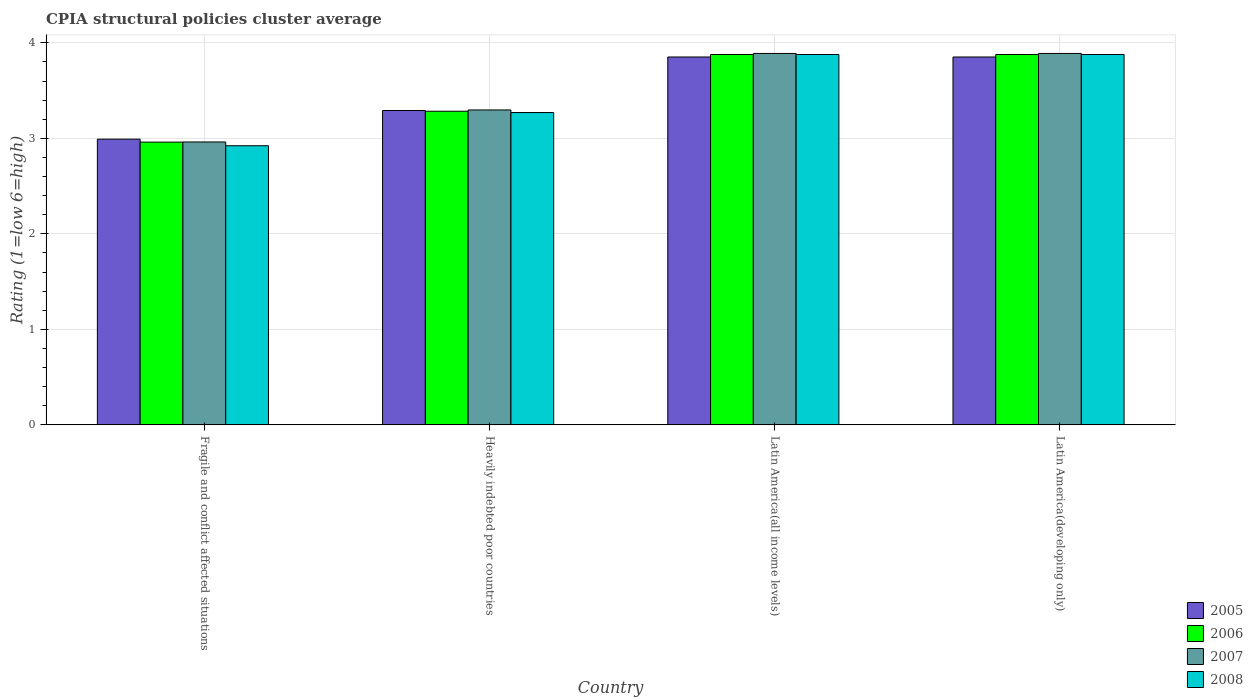Are the number of bars per tick equal to the number of legend labels?
Your answer should be compact. Yes. Are the number of bars on each tick of the X-axis equal?
Offer a terse response. Yes. How many bars are there on the 1st tick from the left?
Your answer should be compact. 4. How many bars are there on the 4th tick from the right?
Offer a very short reply. 4. What is the label of the 3rd group of bars from the left?
Provide a short and direct response. Latin America(all income levels). What is the CPIA rating in 2005 in Latin America(all income levels)?
Ensure brevity in your answer.  3.85. Across all countries, what is the maximum CPIA rating in 2008?
Keep it short and to the point. 3.88. Across all countries, what is the minimum CPIA rating in 2008?
Give a very brief answer. 2.92. In which country was the CPIA rating in 2006 maximum?
Offer a very short reply. Latin America(all income levels). In which country was the CPIA rating in 2006 minimum?
Your answer should be very brief. Fragile and conflict affected situations. What is the total CPIA rating in 2005 in the graph?
Ensure brevity in your answer.  13.99. What is the difference between the CPIA rating in 2008 in Heavily indebted poor countries and that in Latin America(developing only)?
Give a very brief answer. -0.61. What is the difference between the CPIA rating in 2008 in Fragile and conflict affected situations and the CPIA rating in 2006 in Heavily indebted poor countries?
Offer a terse response. -0.36. What is the average CPIA rating in 2007 per country?
Your response must be concise. 3.51. What is the difference between the CPIA rating of/in 2005 and CPIA rating of/in 2008 in Fragile and conflict affected situations?
Your response must be concise. 0.07. What is the ratio of the CPIA rating in 2006 in Fragile and conflict affected situations to that in Latin America(developing only)?
Provide a succinct answer. 0.76. Is the difference between the CPIA rating in 2005 in Fragile and conflict affected situations and Latin America(developing only) greater than the difference between the CPIA rating in 2008 in Fragile and conflict affected situations and Latin America(developing only)?
Your response must be concise. Yes. What is the difference between the highest and the second highest CPIA rating in 2007?
Offer a very short reply. -0.59. What is the difference between the highest and the lowest CPIA rating in 2008?
Keep it short and to the point. 0.96. Is it the case that in every country, the sum of the CPIA rating in 2008 and CPIA rating in 2006 is greater than the sum of CPIA rating in 2005 and CPIA rating in 2007?
Make the answer very short. No. What does the 3rd bar from the right in Heavily indebted poor countries represents?
Make the answer very short. 2006. Are all the bars in the graph horizontal?
Provide a succinct answer. No. How many countries are there in the graph?
Offer a very short reply. 4. Are the values on the major ticks of Y-axis written in scientific E-notation?
Your answer should be very brief. No. Does the graph contain any zero values?
Offer a terse response. No. Does the graph contain grids?
Provide a succinct answer. Yes. Where does the legend appear in the graph?
Offer a terse response. Bottom right. How many legend labels are there?
Offer a terse response. 4. What is the title of the graph?
Your answer should be compact. CPIA structural policies cluster average. Does "2013" appear as one of the legend labels in the graph?
Offer a very short reply. No. What is the label or title of the Y-axis?
Your response must be concise. Rating (1=low 6=high). What is the Rating (1=low 6=high) of 2005 in Fragile and conflict affected situations?
Provide a succinct answer. 2.99. What is the Rating (1=low 6=high) of 2006 in Fragile and conflict affected situations?
Keep it short and to the point. 2.96. What is the Rating (1=low 6=high) in 2007 in Fragile and conflict affected situations?
Your answer should be very brief. 2.96. What is the Rating (1=low 6=high) in 2008 in Fragile and conflict affected situations?
Ensure brevity in your answer.  2.92. What is the Rating (1=low 6=high) in 2005 in Heavily indebted poor countries?
Your answer should be very brief. 3.29. What is the Rating (1=low 6=high) in 2006 in Heavily indebted poor countries?
Offer a very short reply. 3.28. What is the Rating (1=low 6=high) of 2007 in Heavily indebted poor countries?
Your answer should be very brief. 3.3. What is the Rating (1=low 6=high) of 2008 in Heavily indebted poor countries?
Give a very brief answer. 3.27. What is the Rating (1=low 6=high) of 2005 in Latin America(all income levels)?
Offer a terse response. 3.85. What is the Rating (1=low 6=high) in 2006 in Latin America(all income levels)?
Keep it short and to the point. 3.88. What is the Rating (1=low 6=high) of 2007 in Latin America(all income levels)?
Make the answer very short. 3.89. What is the Rating (1=low 6=high) in 2008 in Latin America(all income levels)?
Offer a very short reply. 3.88. What is the Rating (1=low 6=high) of 2005 in Latin America(developing only)?
Keep it short and to the point. 3.85. What is the Rating (1=low 6=high) of 2006 in Latin America(developing only)?
Your answer should be compact. 3.88. What is the Rating (1=low 6=high) of 2007 in Latin America(developing only)?
Give a very brief answer. 3.89. What is the Rating (1=low 6=high) of 2008 in Latin America(developing only)?
Provide a succinct answer. 3.88. Across all countries, what is the maximum Rating (1=low 6=high) of 2005?
Your answer should be compact. 3.85. Across all countries, what is the maximum Rating (1=low 6=high) in 2006?
Your response must be concise. 3.88. Across all countries, what is the maximum Rating (1=low 6=high) of 2007?
Offer a very short reply. 3.89. Across all countries, what is the maximum Rating (1=low 6=high) in 2008?
Keep it short and to the point. 3.88. Across all countries, what is the minimum Rating (1=low 6=high) in 2005?
Your response must be concise. 2.99. Across all countries, what is the minimum Rating (1=low 6=high) in 2006?
Make the answer very short. 2.96. Across all countries, what is the minimum Rating (1=low 6=high) in 2007?
Your answer should be very brief. 2.96. Across all countries, what is the minimum Rating (1=low 6=high) of 2008?
Provide a short and direct response. 2.92. What is the total Rating (1=low 6=high) in 2005 in the graph?
Provide a succinct answer. 13.99. What is the total Rating (1=low 6=high) in 2006 in the graph?
Your answer should be very brief. 14. What is the total Rating (1=low 6=high) in 2007 in the graph?
Your answer should be compact. 14.04. What is the total Rating (1=low 6=high) in 2008 in the graph?
Offer a very short reply. 13.95. What is the difference between the Rating (1=low 6=high) in 2006 in Fragile and conflict affected situations and that in Heavily indebted poor countries?
Offer a terse response. -0.32. What is the difference between the Rating (1=low 6=high) in 2007 in Fragile and conflict affected situations and that in Heavily indebted poor countries?
Make the answer very short. -0.34. What is the difference between the Rating (1=low 6=high) of 2008 in Fragile and conflict affected situations and that in Heavily indebted poor countries?
Give a very brief answer. -0.35. What is the difference between the Rating (1=low 6=high) in 2005 in Fragile and conflict affected situations and that in Latin America(all income levels)?
Make the answer very short. -0.86. What is the difference between the Rating (1=low 6=high) of 2006 in Fragile and conflict affected situations and that in Latin America(all income levels)?
Make the answer very short. -0.92. What is the difference between the Rating (1=low 6=high) of 2007 in Fragile and conflict affected situations and that in Latin America(all income levels)?
Offer a terse response. -0.93. What is the difference between the Rating (1=low 6=high) in 2008 in Fragile and conflict affected situations and that in Latin America(all income levels)?
Give a very brief answer. -0.96. What is the difference between the Rating (1=low 6=high) in 2005 in Fragile and conflict affected situations and that in Latin America(developing only)?
Make the answer very short. -0.86. What is the difference between the Rating (1=low 6=high) of 2006 in Fragile and conflict affected situations and that in Latin America(developing only)?
Offer a terse response. -0.92. What is the difference between the Rating (1=low 6=high) of 2007 in Fragile and conflict affected situations and that in Latin America(developing only)?
Offer a very short reply. -0.93. What is the difference between the Rating (1=low 6=high) in 2008 in Fragile and conflict affected situations and that in Latin America(developing only)?
Give a very brief answer. -0.96. What is the difference between the Rating (1=low 6=high) of 2005 in Heavily indebted poor countries and that in Latin America(all income levels)?
Make the answer very short. -0.56. What is the difference between the Rating (1=low 6=high) in 2006 in Heavily indebted poor countries and that in Latin America(all income levels)?
Offer a very short reply. -0.59. What is the difference between the Rating (1=low 6=high) of 2007 in Heavily indebted poor countries and that in Latin America(all income levels)?
Your answer should be very brief. -0.59. What is the difference between the Rating (1=low 6=high) of 2008 in Heavily indebted poor countries and that in Latin America(all income levels)?
Make the answer very short. -0.61. What is the difference between the Rating (1=low 6=high) of 2005 in Heavily indebted poor countries and that in Latin America(developing only)?
Your answer should be very brief. -0.56. What is the difference between the Rating (1=low 6=high) in 2006 in Heavily indebted poor countries and that in Latin America(developing only)?
Provide a short and direct response. -0.59. What is the difference between the Rating (1=low 6=high) of 2007 in Heavily indebted poor countries and that in Latin America(developing only)?
Offer a very short reply. -0.59. What is the difference between the Rating (1=low 6=high) of 2008 in Heavily indebted poor countries and that in Latin America(developing only)?
Ensure brevity in your answer.  -0.61. What is the difference between the Rating (1=low 6=high) of 2005 in Latin America(all income levels) and that in Latin America(developing only)?
Your answer should be compact. 0. What is the difference between the Rating (1=low 6=high) of 2006 in Latin America(all income levels) and that in Latin America(developing only)?
Offer a very short reply. 0. What is the difference between the Rating (1=low 6=high) of 2008 in Latin America(all income levels) and that in Latin America(developing only)?
Keep it short and to the point. 0. What is the difference between the Rating (1=low 6=high) in 2005 in Fragile and conflict affected situations and the Rating (1=low 6=high) in 2006 in Heavily indebted poor countries?
Ensure brevity in your answer.  -0.29. What is the difference between the Rating (1=low 6=high) in 2005 in Fragile and conflict affected situations and the Rating (1=low 6=high) in 2007 in Heavily indebted poor countries?
Provide a succinct answer. -0.31. What is the difference between the Rating (1=low 6=high) of 2005 in Fragile and conflict affected situations and the Rating (1=low 6=high) of 2008 in Heavily indebted poor countries?
Your response must be concise. -0.28. What is the difference between the Rating (1=low 6=high) of 2006 in Fragile and conflict affected situations and the Rating (1=low 6=high) of 2007 in Heavily indebted poor countries?
Ensure brevity in your answer.  -0.34. What is the difference between the Rating (1=low 6=high) in 2006 in Fragile and conflict affected situations and the Rating (1=low 6=high) in 2008 in Heavily indebted poor countries?
Ensure brevity in your answer.  -0.31. What is the difference between the Rating (1=low 6=high) of 2007 in Fragile and conflict affected situations and the Rating (1=low 6=high) of 2008 in Heavily indebted poor countries?
Provide a short and direct response. -0.31. What is the difference between the Rating (1=low 6=high) in 2005 in Fragile and conflict affected situations and the Rating (1=low 6=high) in 2006 in Latin America(all income levels)?
Provide a short and direct response. -0.89. What is the difference between the Rating (1=low 6=high) in 2005 in Fragile and conflict affected situations and the Rating (1=low 6=high) in 2007 in Latin America(all income levels)?
Make the answer very short. -0.9. What is the difference between the Rating (1=low 6=high) of 2005 in Fragile and conflict affected situations and the Rating (1=low 6=high) of 2008 in Latin America(all income levels)?
Provide a short and direct response. -0.89. What is the difference between the Rating (1=low 6=high) of 2006 in Fragile and conflict affected situations and the Rating (1=low 6=high) of 2007 in Latin America(all income levels)?
Provide a short and direct response. -0.93. What is the difference between the Rating (1=low 6=high) of 2006 in Fragile and conflict affected situations and the Rating (1=low 6=high) of 2008 in Latin America(all income levels)?
Offer a very short reply. -0.92. What is the difference between the Rating (1=low 6=high) in 2007 in Fragile and conflict affected situations and the Rating (1=low 6=high) in 2008 in Latin America(all income levels)?
Make the answer very short. -0.92. What is the difference between the Rating (1=low 6=high) of 2005 in Fragile and conflict affected situations and the Rating (1=low 6=high) of 2006 in Latin America(developing only)?
Your answer should be compact. -0.89. What is the difference between the Rating (1=low 6=high) in 2005 in Fragile and conflict affected situations and the Rating (1=low 6=high) in 2007 in Latin America(developing only)?
Your answer should be very brief. -0.9. What is the difference between the Rating (1=low 6=high) of 2005 in Fragile and conflict affected situations and the Rating (1=low 6=high) of 2008 in Latin America(developing only)?
Your response must be concise. -0.89. What is the difference between the Rating (1=low 6=high) in 2006 in Fragile and conflict affected situations and the Rating (1=low 6=high) in 2007 in Latin America(developing only)?
Make the answer very short. -0.93. What is the difference between the Rating (1=low 6=high) of 2006 in Fragile and conflict affected situations and the Rating (1=low 6=high) of 2008 in Latin America(developing only)?
Your answer should be very brief. -0.92. What is the difference between the Rating (1=low 6=high) in 2007 in Fragile and conflict affected situations and the Rating (1=low 6=high) in 2008 in Latin America(developing only)?
Give a very brief answer. -0.92. What is the difference between the Rating (1=low 6=high) in 2005 in Heavily indebted poor countries and the Rating (1=low 6=high) in 2006 in Latin America(all income levels)?
Keep it short and to the point. -0.59. What is the difference between the Rating (1=low 6=high) of 2005 in Heavily indebted poor countries and the Rating (1=low 6=high) of 2007 in Latin America(all income levels)?
Your answer should be compact. -0.6. What is the difference between the Rating (1=low 6=high) in 2005 in Heavily indebted poor countries and the Rating (1=low 6=high) in 2008 in Latin America(all income levels)?
Your answer should be very brief. -0.59. What is the difference between the Rating (1=low 6=high) in 2006 in Heavily indebted poor countries and the Rating (1=low 6=high) in 2007 in Latin America(all income levels)?
Offer a terse response. -0.61. What is the difference between the Rating (1=low 6=high) of 2006 in Heavily indebted poor countries and the Rating (1=low 6=high) of 2008 in Latin America(all income levels)?
Give a very brief answer. -0.59. What is the difference between the Rating (1=low 6=high) of 2007 in Heavily indebted poor countries and the Rating (1=low 6=high) of 2008 in Latin America(all income levels)?
Give a very brief answer. -0.58. What is the difference between the Rating (1=low 6=high) in 2005 in Heavily indebted poor countries and the Rating (1=low 6=high) in 2006 in Latin America(developing only)?
Offer a terse response. -0.59. What is the difference between the Rating (1=low 6=high) of 2005 in Heavily indebted poor countries and the Rating (1=low 6=high) of 2007 in Latin America(developing only)?
Your answer should be compact. -0.6. What is the difference between the Rating (1=low 6=high) of 2005 in Heavily indebted poor countries and the Rating (1=low 6=high) of 2008 in Latin America(developing only)?
Your answer should be compact. -0.59. What is the difference between the Rating (1=low 6=high) of 2006 in Heavily indebted poor countries and the Rating (1=low 6=high) of 2007 in Latin America(developing only)?
Your answer should be compact. -0.61. What is the difference between the Rating (1=low 6=high) of 2006 in Heavily indebted poor countries and the Rating (1=low 6=high) of 2008 in Latin America(developing only)?
Keep it short and to the point. -0.59. What is the difference between the Rating (1=low 6=high) of 2007 in Heavily indebted poor countries and the Rating (1=low 6=high) of 2008 in Latin America(developing only)?
Your response must be concise. -0.58. What is the difference between the Rating (1=low 6=high) in 2005 in Latin America(all income levels) and the Rating (1=low 6=high) in 2006 in Latin America(developing only)?
Keep it short and to the point. -0.03. What is the difference between the Rating (1=low 6=high) in 2005 in Latin America(all income levels) and the Rating (1=low 6=high) in 2007 in Latin America(developing only)?
Provide a succinct answer. -0.04. What is the difference between the Rating (1=low 6=high) of 2005 in Latin America(all income levels) and the Rating (1=low 6=high) of 2008 in Latin America(developing only)?
Give a very brief answer. -0.03. What is the difference between the Rating (1=low 6=high) in 2006 in Latin America(all income levels) and the Rating (1=low 6=high) in 2007 in Latin America(developing only)?
Provide a short and direct response. -0.01. What is the difference between the Rating (1=low 6=high) in 2007 in Latin America(all income levels) and the Rating (1=low 6=high) in 2008 in Latin America(developing only)?
Offer a very short reply. 0.01. What is the average Rating (1=low 6=high) of 2005 per country?
Give a very brief answer. 3.5. What is the average Rating (1=low 6=high) in 2007 per country?
Offer a very short reply. 3.51. What is the average Rating (1=low 6=high) of 2008 per country?
Provide a succinct answer. 3.49. What is the difference between the Rating (1=low 6=high) of 2005 and Rating (1=low 6=high) of 2006 in Fragile and conflict affected situations?
Your answer should be compact. 0.03. What is the difference between the Rating (1=low 6=high) in 2005 and Rating (1=low 6=high) in 2007 in Fragile and conflict affected situations?
Give a very brief answer. 0.03. What is the difference between the Rating (1=low 6=high) in 2005 and Rating (1=low 6=high) in 2008 in Fragile and conflict affected situations?
Your answer should be very brief. 0.07. What is the difference between the Rating (1=low 6=high) in 2006 and Rating (1=low 6=high) in 2007 in Fragile and conflict affected situations?
Ensure brevity in your answer.  -0. What is the difference between the Rating (1=low 6=high) of 2006 and Rating (1=low 6=high) of 2008 in Fragile and conflict affected situations?
Keep it short and to the point. 0.04. What is the difference between the Rating (1=low 6=high) in 2007 and Rating (1=low 6=high) in 2008 in Fragile and conflict affected situations?
Make the answer very short. 0.04. What is the difference between the Rating (1=low 6=high) of 2005 and Rating (1=low 6=high) of 2006 in Heavily indebted poor countries?
Ensure brevity in your answer.  0.01. What is the difference between the Rating (1=low 6=high) in 2005 and Rating (1=low 6=high) in 2007 in Heavily indebted poor countries?
Offer a terse response. -0.01. What is the difference between the Rating (1=low 6=high) of 2005 and Rating (1=low 6=high) of 2008 in Heavily indebted poor countries?
Provide a succinct answer. 0.02. What is the difference between the Rating (1=low 6=high) of 2006 and Rating (1=low 6=high) of 2007 in Heavily indebted poor countries?
Provide a short and direct response. -0.01. What is the difference between the Rating (1=low 6=high) in 2006 and Rating (1=low 6=high) in 2008 in Heavily indebted poor countries?
Offer a very short reply. 0.01. What is the difference between the Rating (1=low 6=high) of 2007 and Rating (1=low 6=high) of 2008 in Heavily indebted poor countries?
Give a very brief answer. 0.03. What is the difference between the Rating (1=low 6=high) in 2005 and Rating (1=low 6=high) in 2006 in Latin America(all income levels)?
Your response must be concise. -0.03. What is the difference between the Rating (1=low 6=high) in 2005 and Rating (1=low 6=high) in 2007 in Latin America(all income levels)?
Give a very brief answer. -0.04. What is the difference between the Rating (1=low 6=high) of 2005 and Rating (1=low 6=high) of 2008 in Latin America(all income levels)?
Ensure brevity in your answer.  -0.03. What is the difference between the Rating (1=low 6=high) of 2006 and Rating (1=low 6=high) of 2007 in Latin America(all income levels)?
Offer a very short reply. -0.01. What is the difference between the Rating (1=low 6=high) in 2007 and Rating (1=low 6=high) in 2008 in Latin America(all income levels)?
Give a very brief answer. 0.01. What is the difference between the Rating (1=low 6=high) of 2005 and Rating (1=low 6=high) of 2006 in Latin America(developing only)?
Your answer should be very brief. -0.03. What is the difference between the Rating (1=low 6=high) of 2005 and Rating (1=low 6=high) of 2007 in Latin America(developing only)?
Provide a short and direct response. -0.04. What is the difference between the Rating (1=low 6=high) of 2005 and Rating (1=low 6=high) of 2008 in Latin America(developing only)?
Your answer should be compact. -0.03. What is the difference between the Rating (1=low 6=high) of 2006 and Rating (1=low 6=high) of 2007 in Latin America(developing only)?
Your answer should be very brief. -0.01. What is the difference between the Rating (1=low 6=high) of 2006 and Rating (1=low 6=high) of 2008 in Latin America(developing only)?
Your answer should be very brief. 0. What is the difference between the Rating (1=low 6=high) of 2007 and Rating (1=low 6=high) of 2008 in Latin America(developing only)?
Your answer should be compact. 0.01. What is the ratio of the Rating (1=low 6=high) of 2005 in Fragile and conflict affected situations to that in Heavily indebted poor countries?
Ensure brevity in your answer.  0.91. What is the ratio of the Rating (1=low 6=high) of 2006 in Fragile and conflict affected situations to that in Heavily indebted poor countries?
Provide a short and direct response. 0.9. What is the ratio of the Rating (1=low 6=high) of 2007 in Fragile and conflict affected situations to that in Heavily indebted poor countries?
Your answer should be compact. 0.9. What is the ratio of the Rating (1=low 6=high) in 2008 in Fragile and conflict affected situations to that in Heavily indebted poor countries?
Offer a very short reply. 0.89. What is the ratio of the Rating (1=low 6=high) of 2005 in Fragile and conflict affected situations to that in Latin America(all income levels)?
Ensure brevity in your answer.  0.78. What is the ratio of the Rating (1=low 6=high) in 2006 in Fragile and conflict affected situations to that in Latin America(all income levels)?
Offer a terse response. 0.76. What is the ratio of the Rating (1=low 6=high) of 2007 in Fragile and conflict affected situations to that in Latin America(all income levels)?
Provide a succinct answer. 0.76. What is the ratio of the Rating (1=low 6=high) in 2008 in Fragile and conflict affected situations to that in Latin America(all income levels)?
Make the answer very short. 0.75. What is the ratio of the Rating (1=low 6=high) of 2005 in Fragile and conflict affected situations to that in Latin America(developing only)?
Your response must be concise. 0.78. What is the ratio of the Rating (1=low 6=high) of 2006 in Fragile and conflict affected situations to that in Latin America(developing only)?
Make the answer very short. 0.76. What is the ratio of the Rating (1=low 6=high) in 2007 in Fragile and conflict affected situations to that in Latin America(developing only)?
Your answer should be compact. 0.76. What is the ratio of the Rating (1=low 6=high) of 2008 in Fragile and conflict affected situations to that in Latin America(developing only)?
Offer a terse response. 0.75. What is the ratio of the Rating (1=low 6=high) of 2005 in Heavily indebted poor countries to that in Latin America(all income levels)?
Your answer should be compact. 0.85. What is the ratio of the Rating (1=low 6=high) in 2006 in Heavily indebted poor countries to that in Latin America(all income levels)?
Your response must be concise. 0.85. What is the ratio of the Rating (1=low 6=high) of 2007 in Heavily indebted poor countries to that in Latin America(all income levels)?
Make the answer very short. 0.85. What is the ratio of the Rating (1=low 6=high) of 2008 in Heavily indebted poor countries to that in Latin America(all income levels)?
Provide a short and direct response. 0.84. What is the ratio of the Rating (1=low 6=high) of 2005 in Heavily indebted poor countries to that in Latin America(developing only)?
Make the answer very short. 0.85. What is the ratio of the Rating (1=low 6=high) of 2006 in Heavily indebted poor countries to that in Latin America(developing only)?
Keep it short and to the point. 0.85. What is the ratio of the Rating (1=low 6=high) in 2007 in Heavily indebted poor countries to that in Latin America(developing only)?
Give a very brief answer. 0.85. What is the ratio of the Rating (1=low 6=high) in 2008 in Heavily indebted poor countries to that in Latin America(developing only)?
Your response must be concise. 0.84. What is the ratio of the Rating (1=low 6=high) of 2008 in Latin America(all income levels) to that in Latin America(developing only)?
Ensure brevity in your answer.  1. What is the difference between the highest and the second highest Rating (1=low 6=high) in 2005?
Ensure brevity in your answer.  0. What is the difference between the highest and the second highest Rating (1=low 6=high) in 2006?
Provide a short and direct response. 0. What is the difference between the highest and the lowest Rating (1=low 6=high) of 2005?
Your answer should be compact. 0.86. What is the difference between the highest and the lowest Rating (1=low 6=high) in 2006?
Ensure brevity in your answer.  0.92. What is the difference between the highest and the lowest Rating (1=low 6=high) in 2007?
Offer a terse response. 0.93. What is the difference between the highest and the lowest Rating (1=low 6=high) in 2008?
Offer a very short reply. 0.96. 